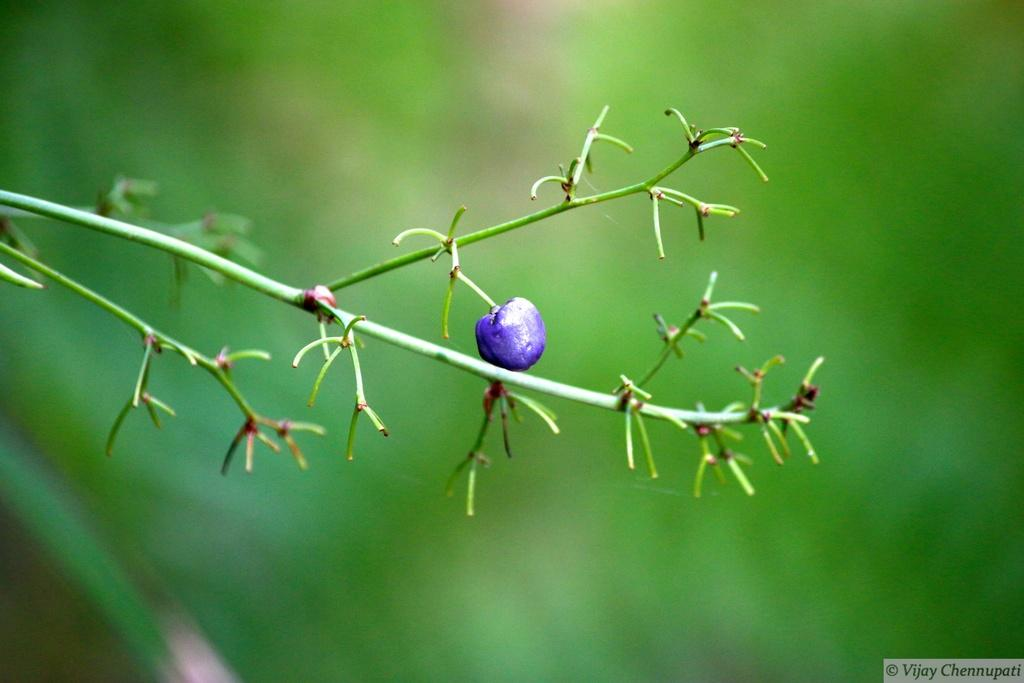What is present on the plant in the image? There is a fruit on the plant in the image. How would you describe the overall focus of the image? The background of the image is blurry, indicating that the focus is on the plant and fruit. Can you make out any specific details about the background? There might be trees in the background, but they are not clearly visible due to the blur. What information can be found in the bottom right corner of the image? There is text in the bottom right corner of the image. What type of calculator is the grandfather using in the image? There is no grandfather or calculator present in the image; it features a fruit on a plant with a blurry background and text in the bottom right corner. 